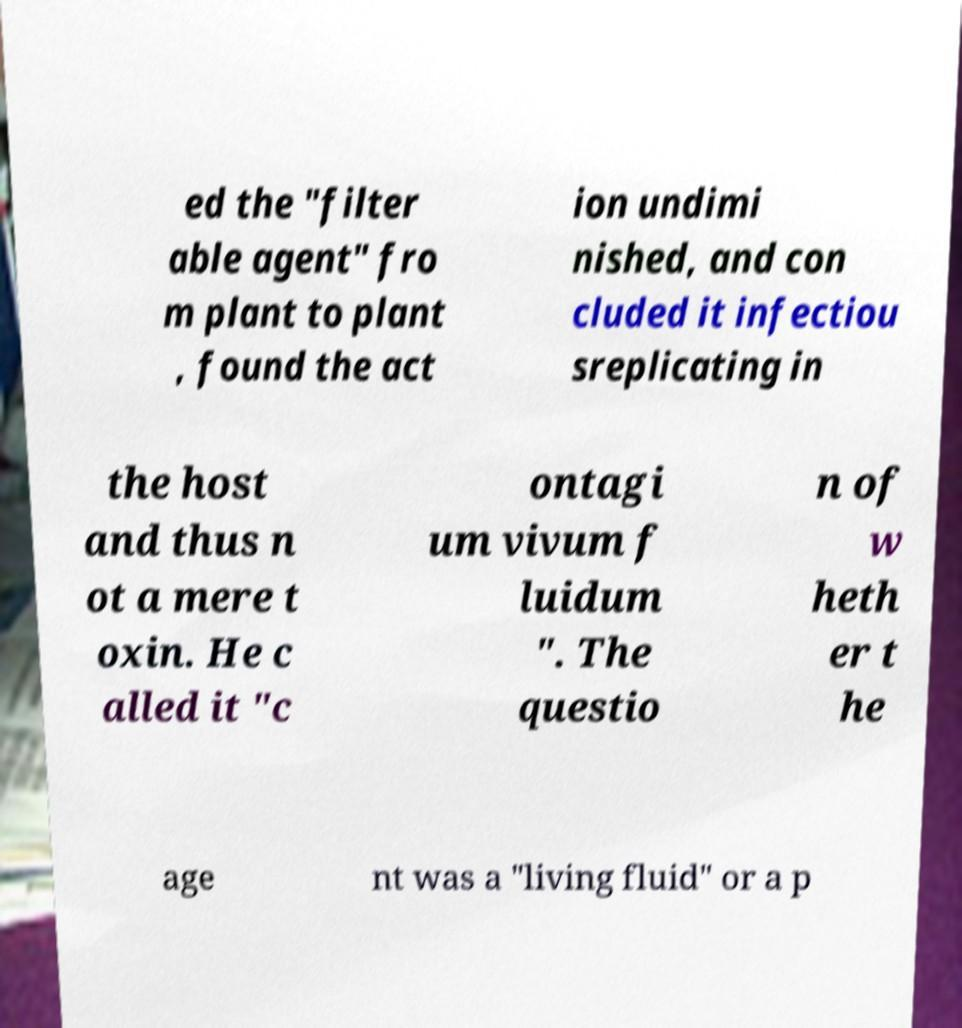Please read and relay the text visible in this image. What does it say? ed the "filter able agent" fro m plant to plant , found the act ion undimi nished, and con cluded it infectiou sreplicating in the host and thus n ot a mere t oxin. He c alled it "c ontagi um vivum f luidum ". The questio n of w heth er t he age nt was a "living fluid" or a p 